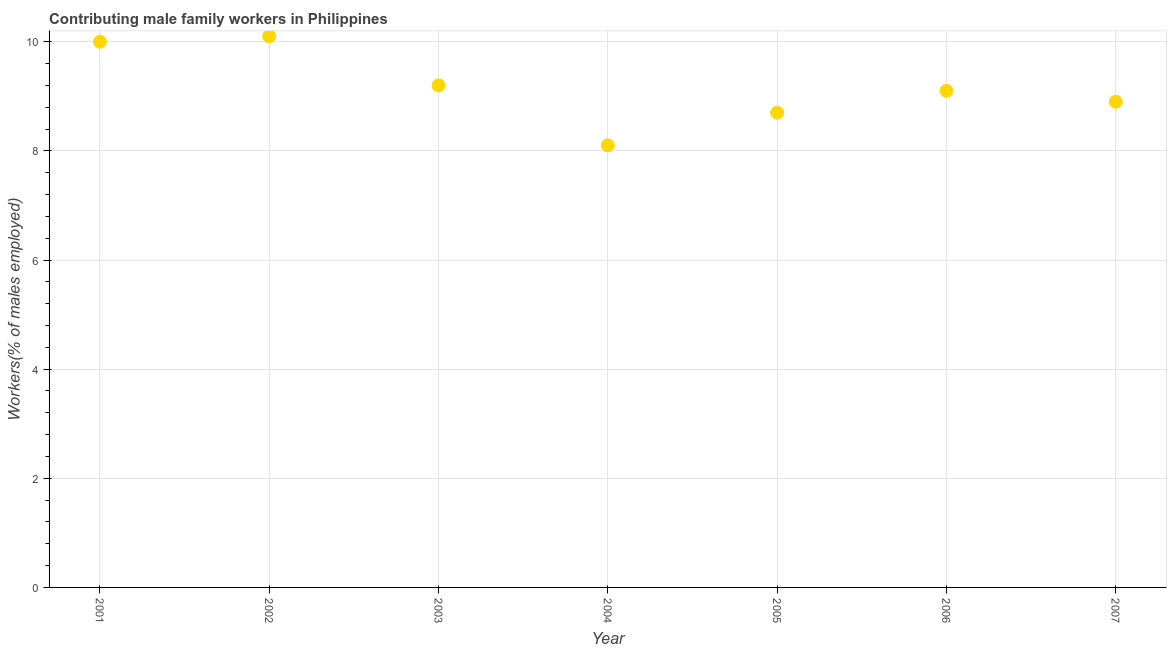What is the contributing male family workers in 2003?
Provide a succinct answer. 9.2. Across all years, what is the maximum contributing male family workers?
Provide a short and direct response. 10.1. Across all years, what is the minimum contributing male family workers?
Your response must be concise. 8.1. What is the sum of the contributing male family workers?
Make the answer very short. 64.1. What is the difference between the contributing male family workers in 2005 and 2007?
Your answer should be very brief. -0.2. What is the average contributing male family workers per year?
Provide a succinct answer. 9.16. What is the median contributing male family workers?
Make the answer very short. 9.1. What is the ratio of the contributing male family workers in 2004 to that in 2007?
Provide a short and direct response. 0.91. Is the contributing male family workers in 2004 less than that in 2005?
Your answer should be very brief. Yes. What is the difference between the highest and the second highest contributing male family workers?
Provide a succinct answer. 0.1. Is the sum of the contributing male family workers in 2002 and 2006 greater than the maximum contributing male family workers across all years?
Your response must be concise. Yes. What is the difference between the highest and the lowest contributing male family workers?
Provide a short and direct response. 2. How many years are there in the graph?
Keep it short and to the point. 7. What is the difference between two consecutive major ticks on the Y-axis?
Your answer should be compact. 2. Are the values on the major ticks of Y-axis written in scientific E-notation?
Provide a short and direct response. No. Does the graph contain any zero values?
Give a very brief answer. No. Does the graph contain grids?
Your answer should be very brief. Yes. What is the title of the graph?
Provide a short and direct response. Contributing male family workers in Philippines. What is the label or title of the Y-axis?
Ensure brevity in your answer.  Workers(% of males employed). What is the Workers(% of males employed) in 2002?
Make the answer very short. 10.1. What is the Workers(% of males employed) in 2003?
Your answer should be very brief. 9.2. What is the Workers(% of males employed) in 2004?
Your answer should be very brief. 8.1. What is the Workers(% of males employed) in 2005?
Provide a succinct answer. 8.7. What is the Workers(% of males employed) in 2006?
Provide a succinct answer. 9.1. What is the Workers(% of males employed) in 2007?
Offer a very short reply. 8.9. What is the difference between the Workers(% of males employed) in 2001 and 2002?
Your response must be concise. -0.1. What is the difference between the Workers(% of males employed) in 2001 and 2003?
Your answer should be very brief. 0.8. What is the difference between the Workers(% of males employed) in 2001 and 2004?
Make the answer very short. 1.9. What is the difference between the Workers(% of males employed) in 2001 and 2007?
Keep it short and to the point. 1.1. What is the difference between the Workers(% of males employed) in 2002 and 2004?
Make the answer very short. 2. What is the difference between the Workers(% of males employed) in 2002 and 2005?
Provide a short and direct response. 1.4. What is the difference between the Workers(% of males employed) in 2004 and 2005?
Your response must be concise. -0.6. What is the difference between the Workers(% of males employed) in 2005 and 2007?
Your response must be concise. -0.2. What is the difference between the Workers(% of males employed) in 2006 and 2007?
Offer a very short reply. 0.2. What is the ratio of the Workers(% of males employed) in 2001 to that in 2003?
Make the answer very short. 1.09. What is the ratio of the Workers(% of males employed) in 2001 to that in 2004?
Provide a succinct answer. 1.24. What is the ratio of the Workers(% of males employed) in 2001 to that in 2005?
Keep it short and to the point. 1.15. What is the ratio of the Workers(% of males employed) in 2001 to that in 2006?
Provide a short and direct response. 1.1. What is the ratio of the Workers(% of males employed) in 2001 to that in 2007?
Offer a terse response. 1.12. What is the ratio of the Workers(% of males employed) in 2002 to that in 2003?
Give a very brief answer. 1.1. What is the ratio of the Workers(% of males employed) in 2002 to that in 2004?
Give a very brief answer. 1.25. What is the ratio of the Workers(% of males employed) in 2002 to that in 2005?
Provide a short and direct response. 1.16. What is the ratio of the Workers(% of males employed) in 2002 to that in 2006?
Make the answer very short. 1.11. What is the ratio of the Workers(% of males employed) in 2002 to that in 2007?
Offer a very short reply. 1.14. What is the ratio of the Workers(% of males employed) in 2003 to that in 2004?
Give a very brief answer. 1.14. What is the ratio of the Workers(% of males employed) in 2003 to that in 2005?
Provide a short and direct response. 1.06. What is the ratio of the Workers(% of males employed) in 2003 to that in 2006?
Your answer should be very brief. 1.01. What is the ratio of the Workers(% of males employed) in 2003 to that in 2007?
Ensure brevity in your answer.  1.03. What is the ratio of the Workers(% of males employed) in 2004 to that in 2005?
Your response must be concise. 0.93. What is the ratio of the Workers(% of males employed) in 2004 to that in 2006?
Provide a succinct answer. 0.89. What is the ratio of the Workers(% of males employed) in 2004 to that in 2007?
Your response must be concise. 0.91. What is the ratio of the Workers(% of males employed) in 2005 to that in 2006?
Provide a short and direct response. 0.96. What is the ratio of the Workers(% of males employed) in 2006 to that in 2007?
Offer a very short reply. 1.02. 